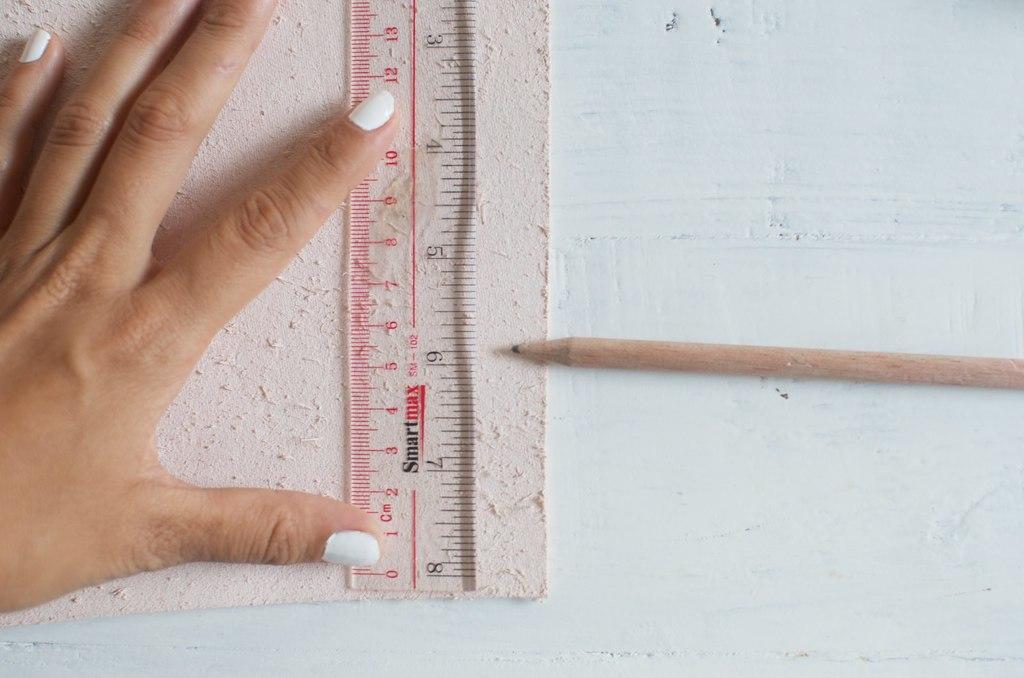Is this made by smartmax?
Your answer should be very brief. Yes. What number is the pencil ponting to?
Your answer should be compact. 6. 